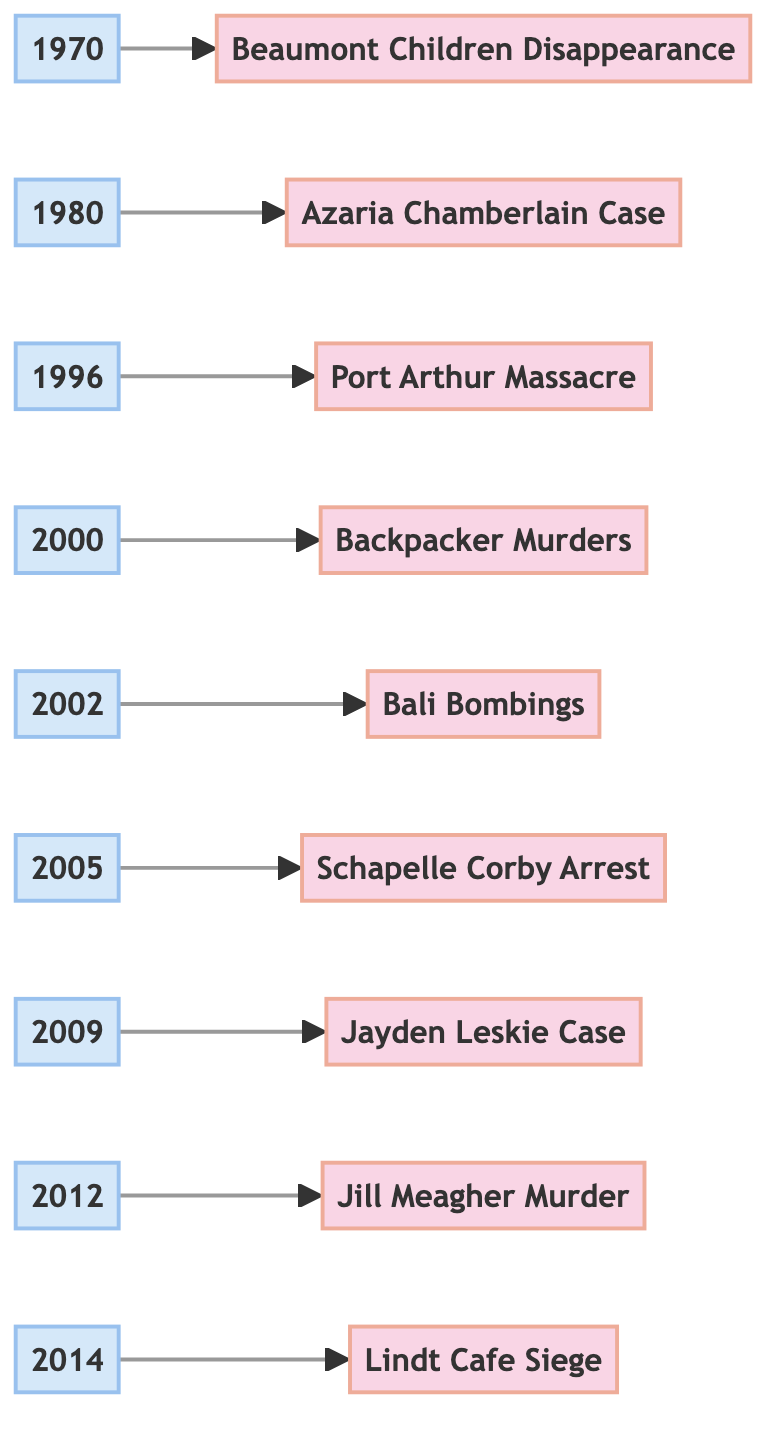What is the first event listed in the timeline? The first event in the timeline is the disappearance of the Beaumont Children, which is indicated by the first connection from the node labeled "1970."
Answer: The Disappearance of the Beaumont Children What year did the Port Arthur Massacre occur? The timeline shows the event labeled "Port Arthur Massacre" connected to the node "1996," indicating that this event occurred in that year.
Answer: 1996 Which event took place in 2005? The event listed under the year "2005" in the timeline is the arrest of Schapelle Corby, evident from the connection to the node labeled "Corby."
Answer: Schapelle Corby Arrest How many events are represented in the flowchart? By counting the number of event nodes connected to the year nodes in the diagram, there are a total of 9 events represented.
Answer: 9 Which event directly follows the Bali Bombings in the timeline? The flowchart shows that the event labeled "Schapelle Corby Arrest" follows the "Bali Bombings" event, as indicated by the positioning of the nodes.
Answer: Schapelle Corby Arrest What is the last event on the timeline? The last event in the timeline is the Lindt Cafe Siege, which is the final connection from the node labeled "2014."
Answer: Lindt Cafe Siege Which event is associated with the year 2000? The timeline connects the year "2000" to the event labeled "Backpacker Murders," specifically detailing the case of Ivan Milat.
Answer: Backpacker Murders What is the connection between Jill Meagher and the year 2012? The diagram shows that Jill Meagher's murder is associated with the year "2012," as indicated by the connection from the node labeled "2012" to the event node.
Answer: The Murder of Jill Meagher Which event had political repercussions in Australia? The Bali Bombings event is explicitly noted in the diagram to have significant political repercussions, indicated by its description.
Answer: The Bali Bombings 